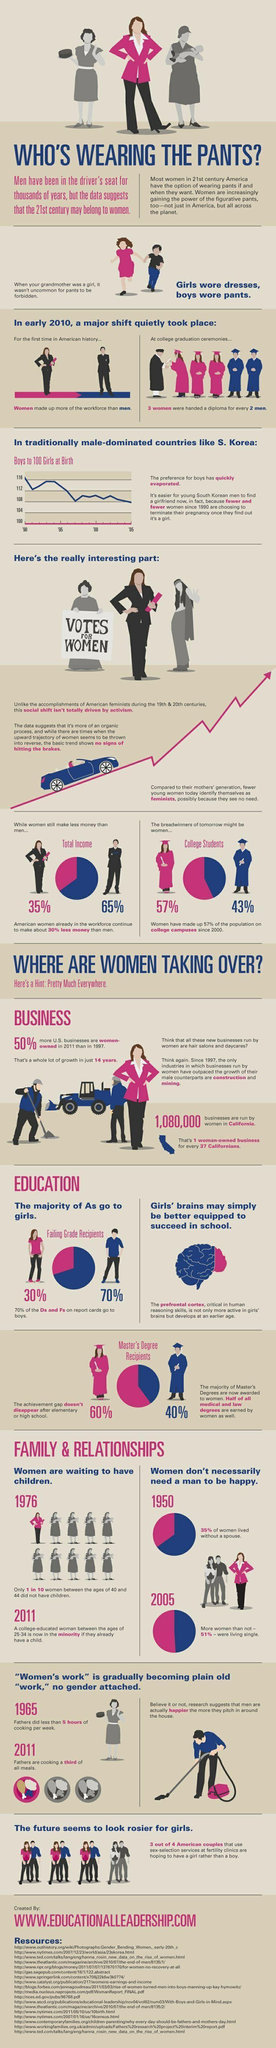What is the percentage of women enrolled in college since 2000, 35%, 65%, 57%, or 43%?
Answer the question with a short phrase. 57% How many meals out of three are being cooked by women 1, 2, or 3? 2 What was the increase in percentage of single women from 1950 to 2005? 16% 